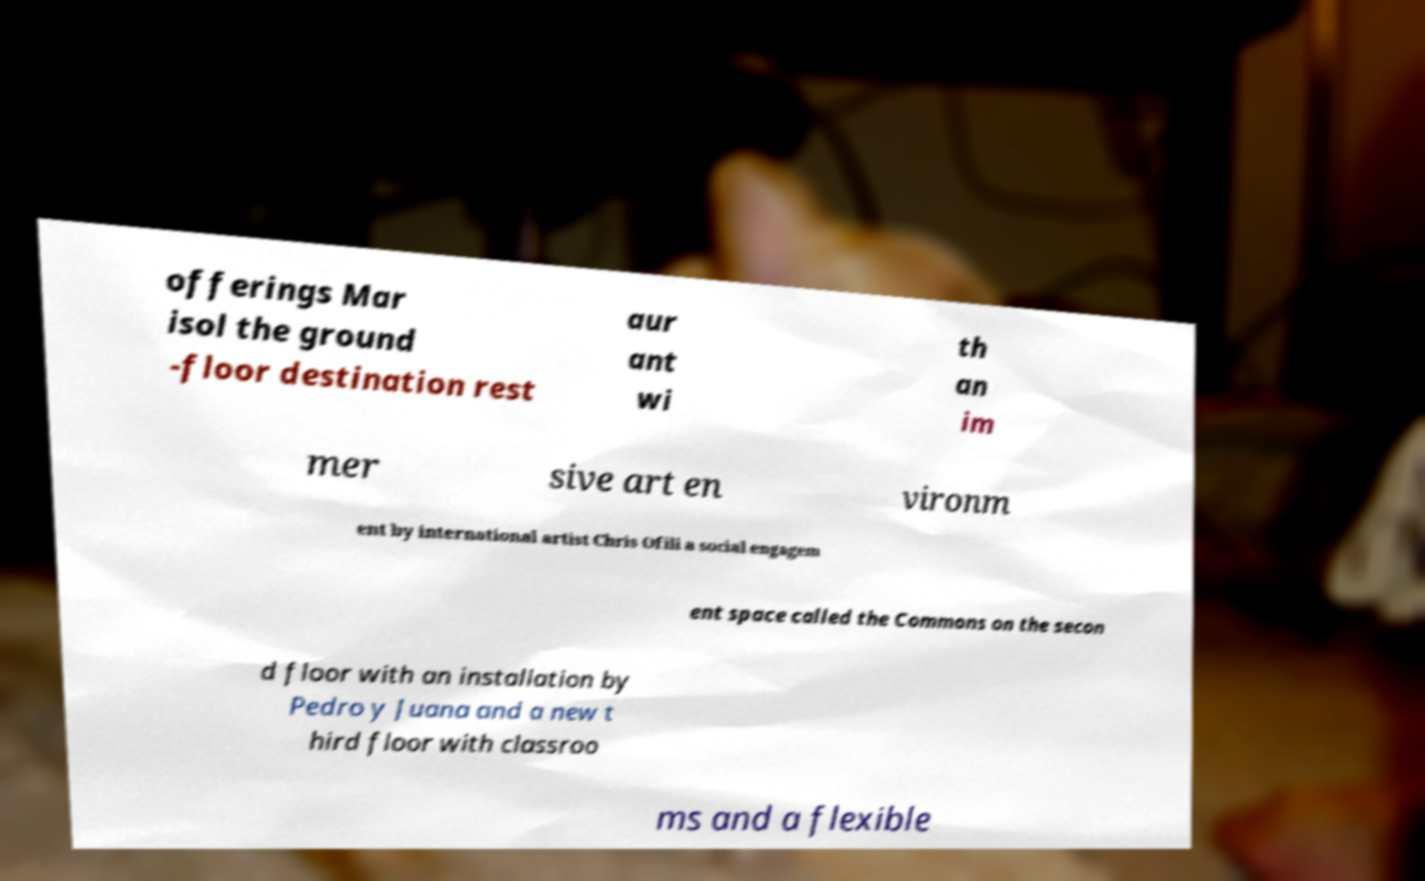What messages or text are displayed in this image? I need them in a readable, typed format. offerings Mar isol the ground -floor destination rest aur ant wi th an im mer sive art en vironm ent by international artist Chris Ofili a social engagem ent space called the Commons on the secon d floor with an installation by Pedro y Juana and a new t hird floor with classroo ms and a flexible 